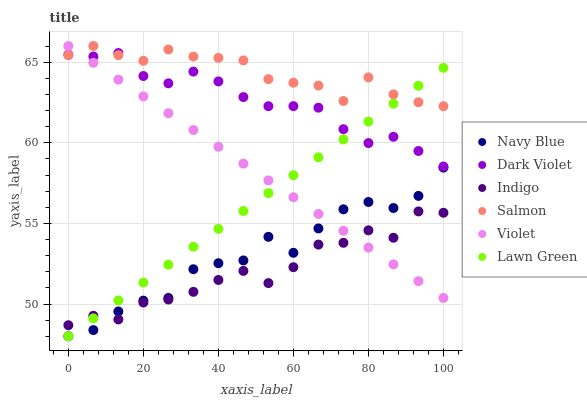Does Indigo have the minimum area under the curve?
Answer yes or no. Yes. Does Salmon have the maximum area under the curve?
Answer yes or no. Yes. Does Navy Blue have the minimum area under the curve?
Answer yes or no. No. Does Navy Blue have the maximum area under the curve?
Answer yes or no. No. Is Lawn Green the smoothest?
Answer yes or no. Yes. Is Navy Blue the roughest?
Answer yes or no. Yes. Is Indigo the smoothest?
Answer yes or no. No. Is Indigo the roughest?
Answer yes or no. No. Does Lawn Green have the lowest value?
Answer yes or no. Yes. Does Indigo have the lowest value?
Answer yes or no. No. Does Violet have the highest value?
Answer yes or no. Yes. Does Navy Blue have the highest value?
Answer yes or no. No. Is Indigo less than Dark Violet?
Answer yes or no. Yes. Is Dark Violet greater than Navy Blue?
Answer yes or no. Yes. Does Navy Blue intersect Violet?
Answer yes or no. Yes. Is Navy Blue less than Violet?
Answer yes or no. No. Is Navy Blue greater than Violet?
Answer yes or no. No. Does Indigo intersect Dark Violet?
Answer yes or no. No. 